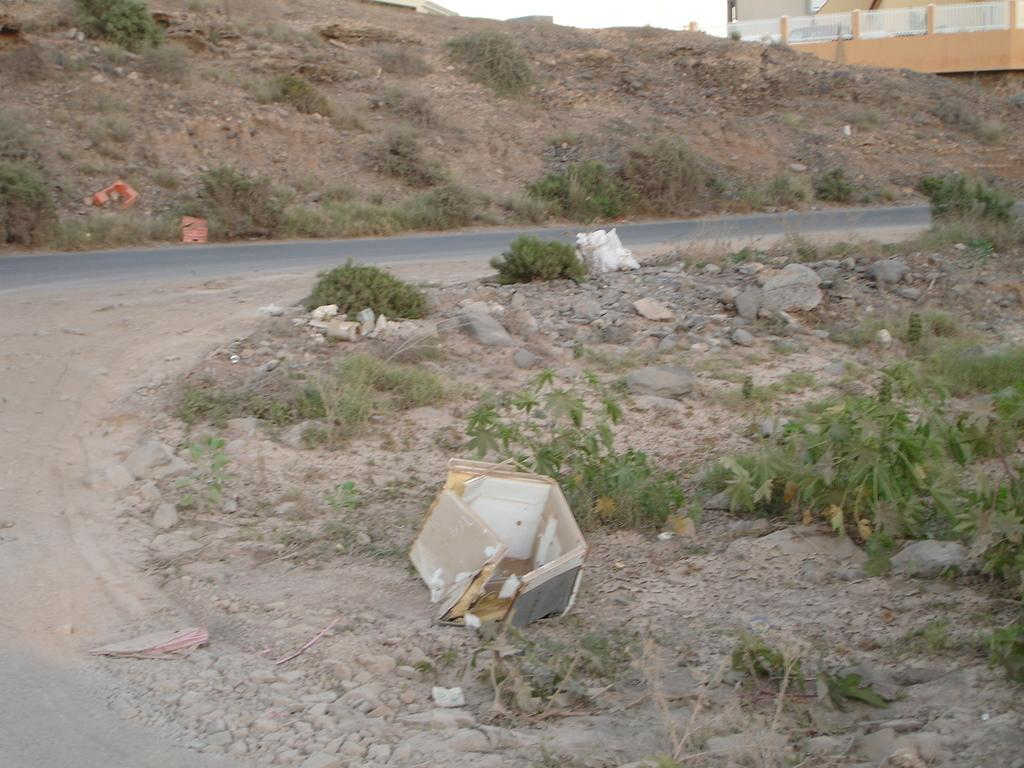What is the main feature of the image? There is a road in the image. What else can be seen alongside the road? There are rocks and plants in the image. What is located at the back of the image? There is a wall in the back of the image. How many wrens are perched on the wall in the image? There are no wrens present in the image. What type of attraction is visible in the image? There is no attraction visible in the image; it features a road, rocks, plants, and a wall. 